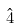<formula> <loc_0><loc_0><loc_500><loc_500>\hat { 4 }</formula> 